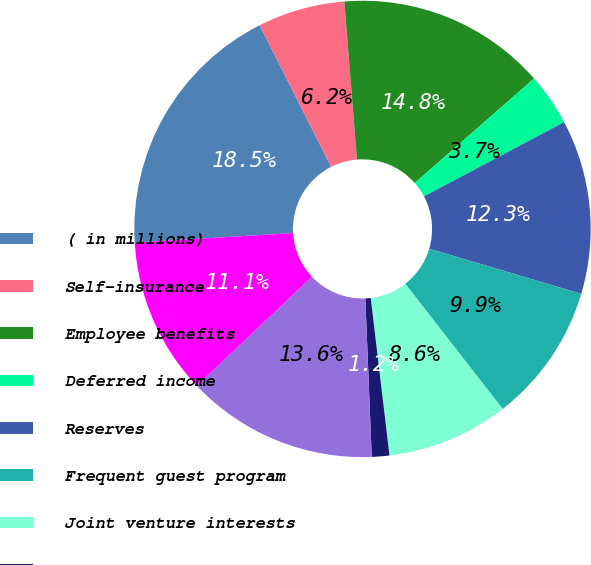Convert chart. <chart><loc_0><loc_0><loc_500><loc_500><pie_chart><fcel>( in millions)<fcel>Self-insurance<fcel>Employee benefits<fcel>Deferred income<fcel>Reserves<fcel>Frequent guest program<fcel>Joint venture interests<fcel>ASC 740 deferred taxes (1)<fcel>Tax credits<fcel>Net operating loss<nl><fcel>18.51%<fcel>6.17%<fcel>14.81%<fcel>3.71%<fcel>12.34%<fcel>9.88%<fcel>8.64%<fcel>1.24%<fcel>13.58%<fcel>11.11%<nl></chart> 